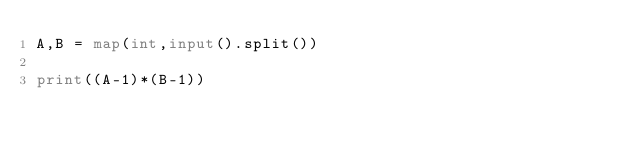Convert code to text. <code><loc_0><loc_0><loc_500><loc_500><_Python_>A,B = map(int,input().split())

print((A-1)*(B-1))</code> 